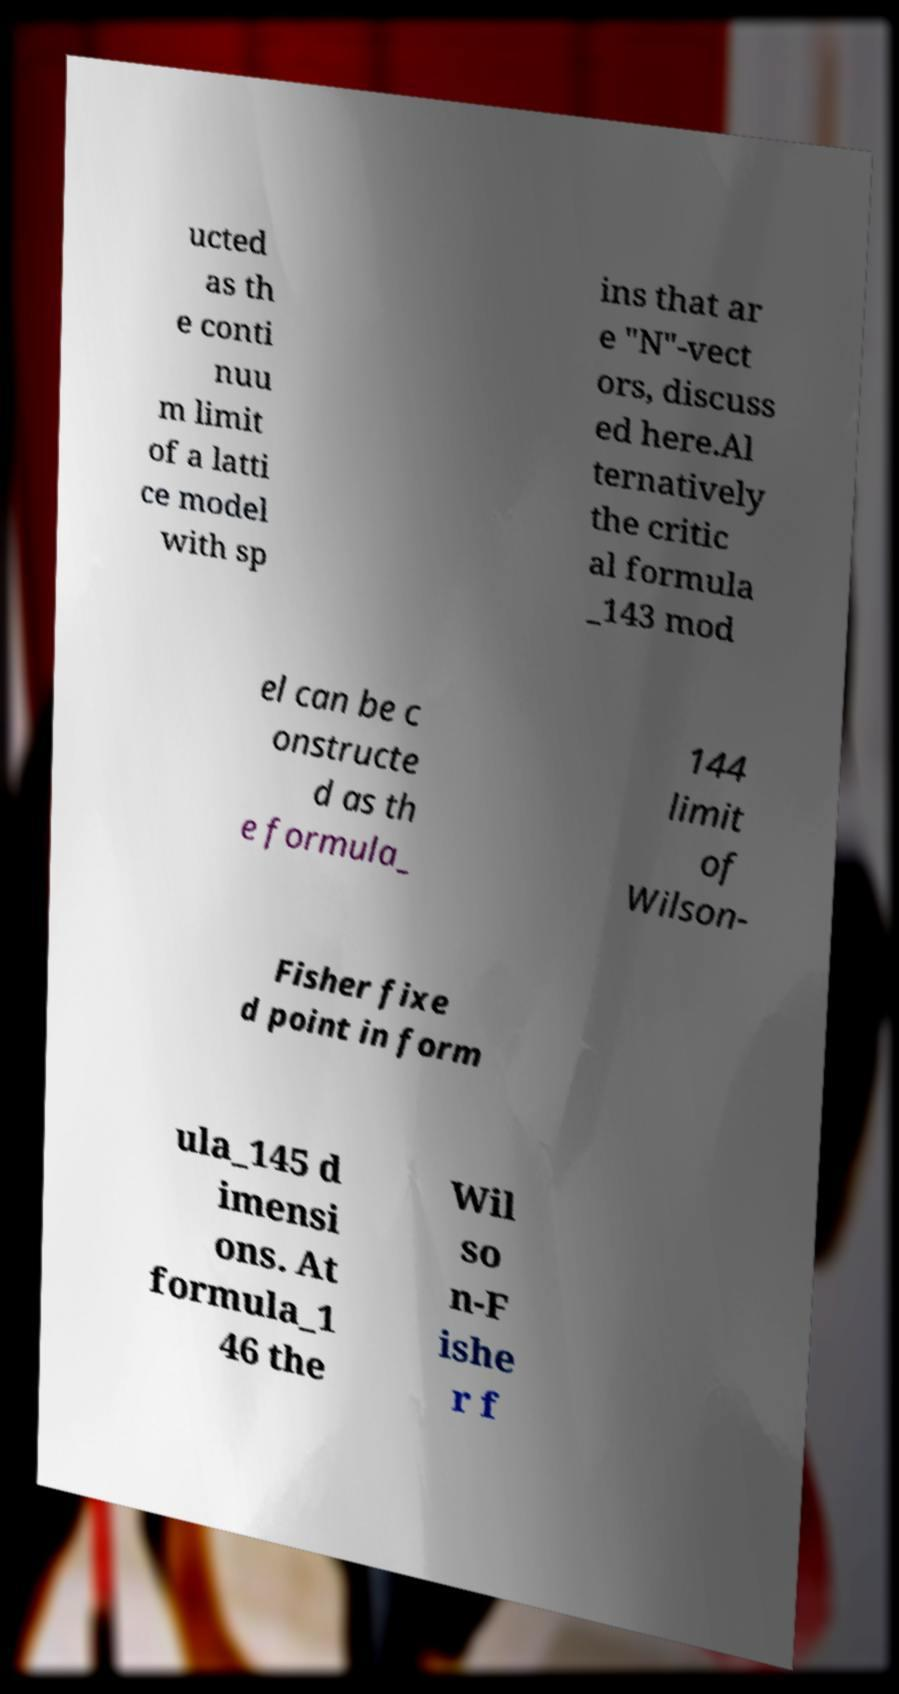Can you read and provide the text displayed in the image?This photo seems to have some interesting text. Can you extract and type it out for me? ucted as th e conti nuu m limit of a latti ce model with sp ins that ar e "N"-vect ors, discuss ed here.Al ternatively the critic al formula _143 mod el can be c onstructe d as th e formula_ 144 limit of Wilson- Fisher fixe d point in form ula_145 d imensi ons. At formula_1 46 the Wil so n-F ishe r f 